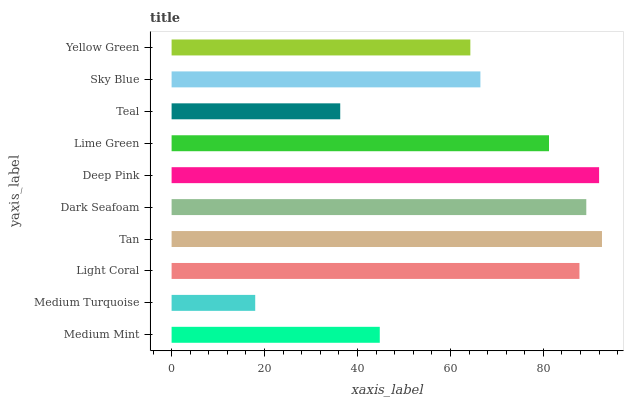Is Medium Turquoise the minimum?
Answer yes or no. Yes. Is Tan the maximum?
Answer yes or no. Yes. Is Light Coral the minimum?
Answer yes or no. No. Is Light Coral the maximum?
Answer yes or no. No. Is Light Coral greater than Medium Turquoise?
Answer yes or no. Yes. Is Medium Turquoise less than Light Coral?
Answer yes or no. Yes. Is Medium Turquoise greater than Light Coral?
Answer yes or no. No. Is Light Coral less than Medium Turquoise?
Answer yes or no. No. Is Lime Green the high median?
Answer yes or no. Yes. Is Sky Blue the low median?
Answer yes or no. Yes. Is Medium Turquoise the high median?
Answer yes or no. No. Is Tan the low median?
Answer yes or no. No. 